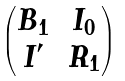<formula> <loc_0><loc_0><loc_500><loc_500>\begin{pmatrix} B _ { 1 } & I _ { 0 } \\ I ^ { \prime } & R _ { 1 } \end{pmatrix}</formula> 